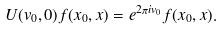<formula> <loc_0><loc_0><loc_500><loc_500>U ( v _ { 0 } , 0 ) f ( x _ { 0 } , x ) = e ^ { 2 \pi i v _ { 0 } } f ( x _ { 0 } , x ) .</formula> 